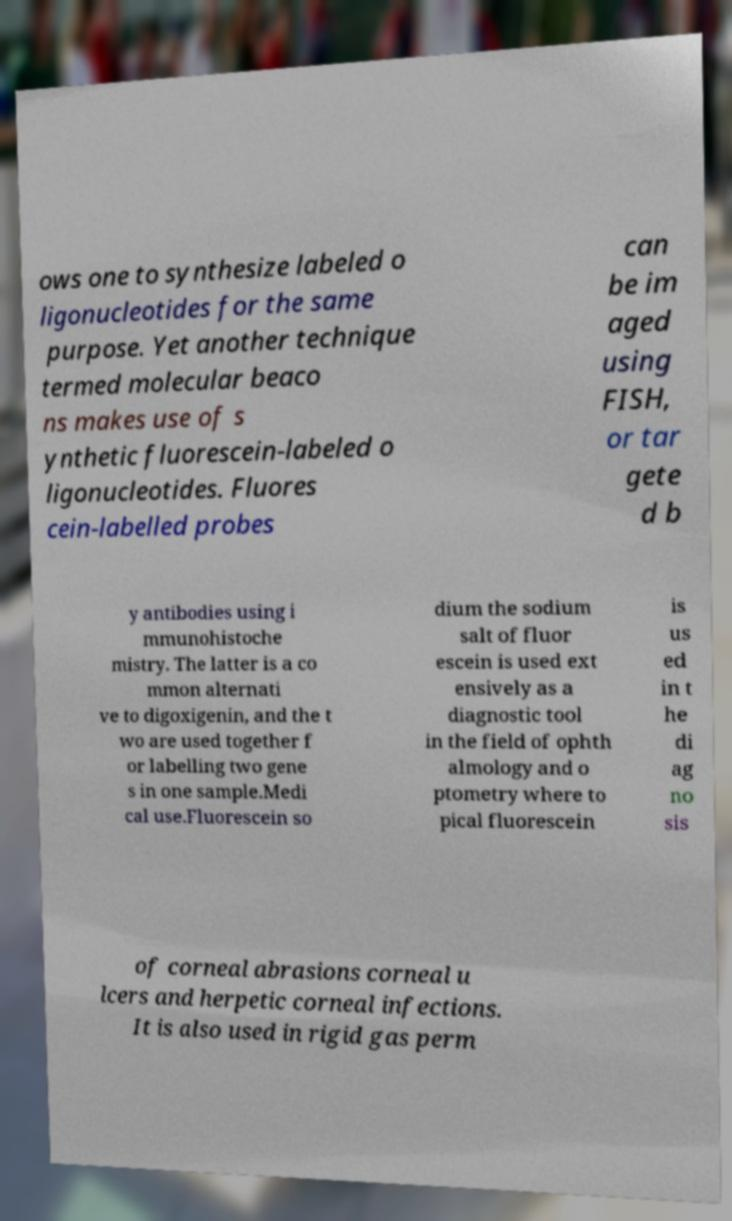Can you accurately transcribe the text from the provided image for me? ows one to synthesize labeled o ligonucleotides for the same purpose. Yet another technique termed molecular beaco ns makes use of s ynthetic fluorescein-labeled o ligonucleotides. Fluores cein-labelled probes can be im aged using FISH, or tar gete d b y antibodies using i mmunohistoche mistry. The latter is a co mmon alternati ve to digoxigenin, and the t wo are used together f or labelling two gene s in one sample.Medi cal use.Fluorescein so dium the sodium salt of fluor escein is used ext ensively as a diagnostic tool in the field of ophth almology and o ptometry where to pical fluorescein is us ed in t he di ag no sis of corneal abrasions corneal u lcers and herpetic corneal infections. It is also used in rigid gas perm 